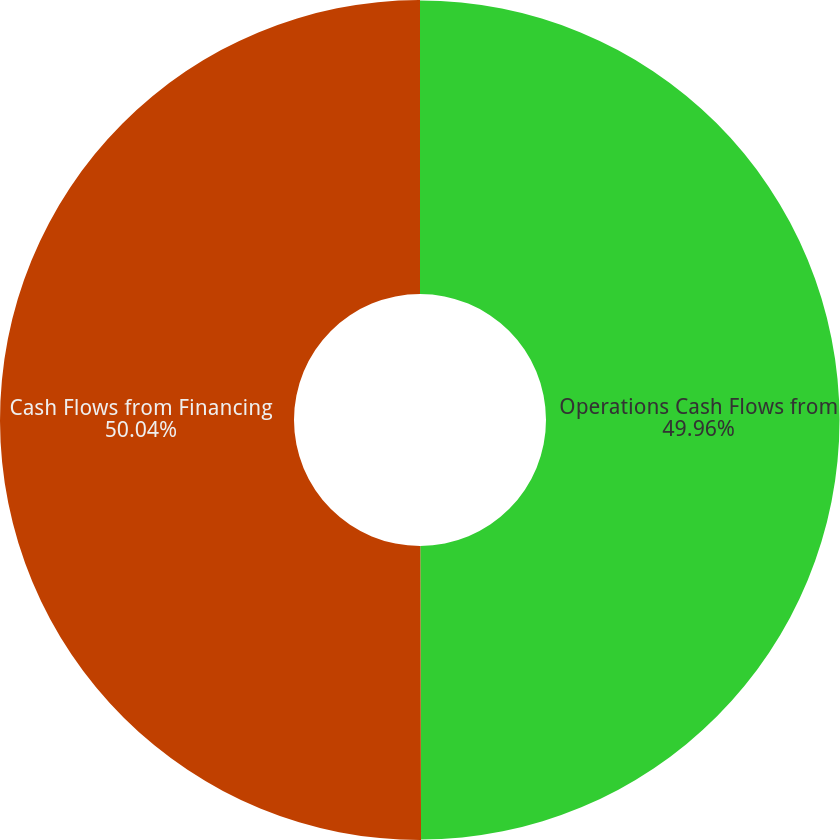Convert chart. <chart><loc_0><loc_0><loc_500><loc_500><pie_chart><fcel>Operations Cash Flows from<fcel>Cash Flows from Financing<nl><fcel>49.96%<fcel>50.04%<nl></chart> 